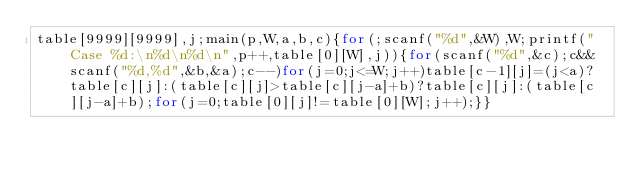<code> <loc_0><loc_0><loc_500><loc_500><_C_>table[9999][9999],j;main(p,W,a,b,c){for(;scanf("%d",&W),W;printf("Case %d:\n%d\n%d\n",p++,table[0][W],j)){for(scanf("%d",&c);c&&scanf("%d,%d",&b,&a);c--)for(j=0;j<=W;j++)table[c-1][j]=(j<a)?table[c][j]:(table[c][j]>table[c][j-a]+b)?table[c][j]:(table[c][j-a]+b);for(j=0;table[0][j]!=table[0][W];j++);}}</code> 